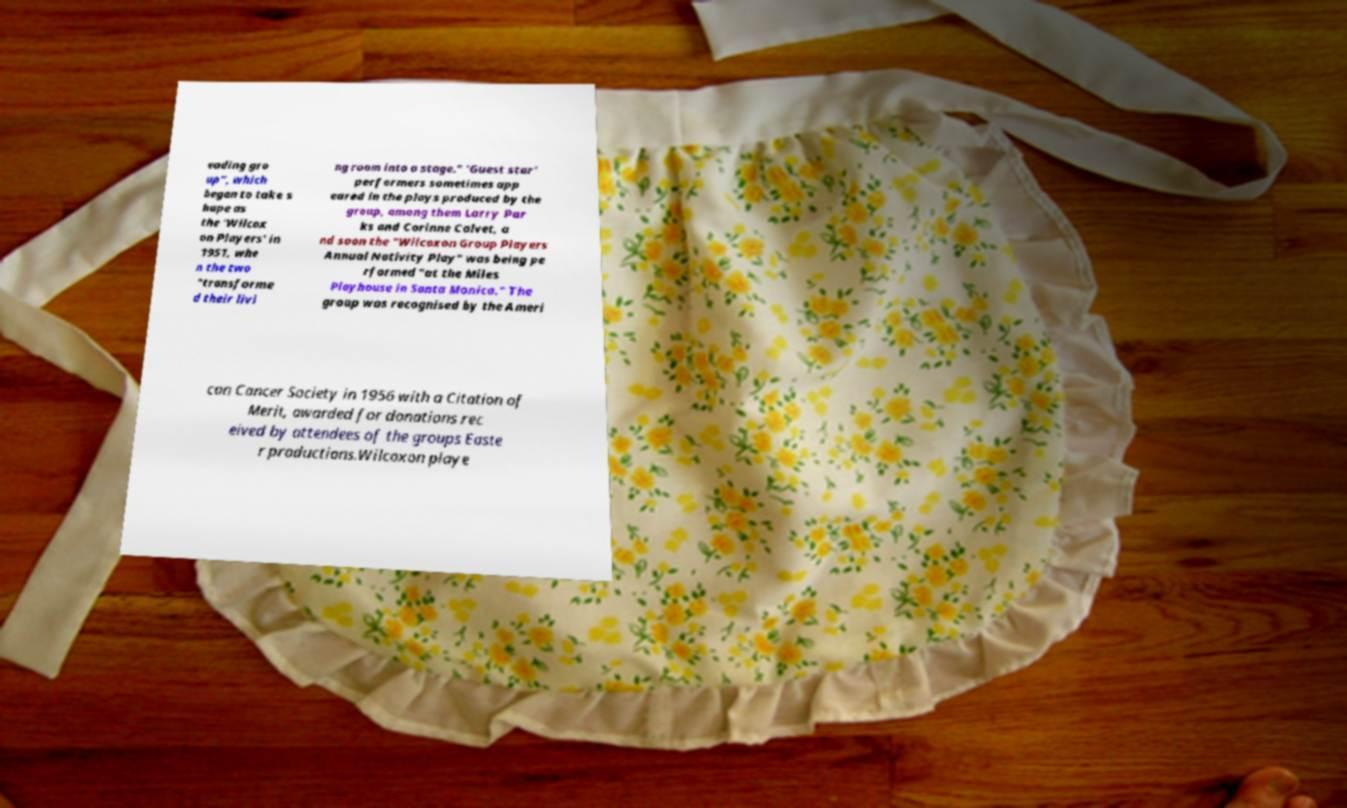Can you read and provide the text displayed in the image?This photo seems to have some interesting text. Can you extract and type it out for me? eading gro up", which began to take s hape as the 'Wilcox on Players' in 1951, whe n the two "transforme d their livi ng room into a stage." 'Guest star' performers sometimes app eared in the plays produced by the group, among them Larry Par ks and Corinne Calvet, a nd soon the "Wilcoxon Group Players Annual Nativity Play" was being pe rformed "at the Miles Playhouse in Santa Monica." The group was recognised by the Ameri can Cancer Society in 1956 with a Citation of Merit, awarded for donations rec eived by attendees of the groups Easte r productions.Wilcoxon playe 